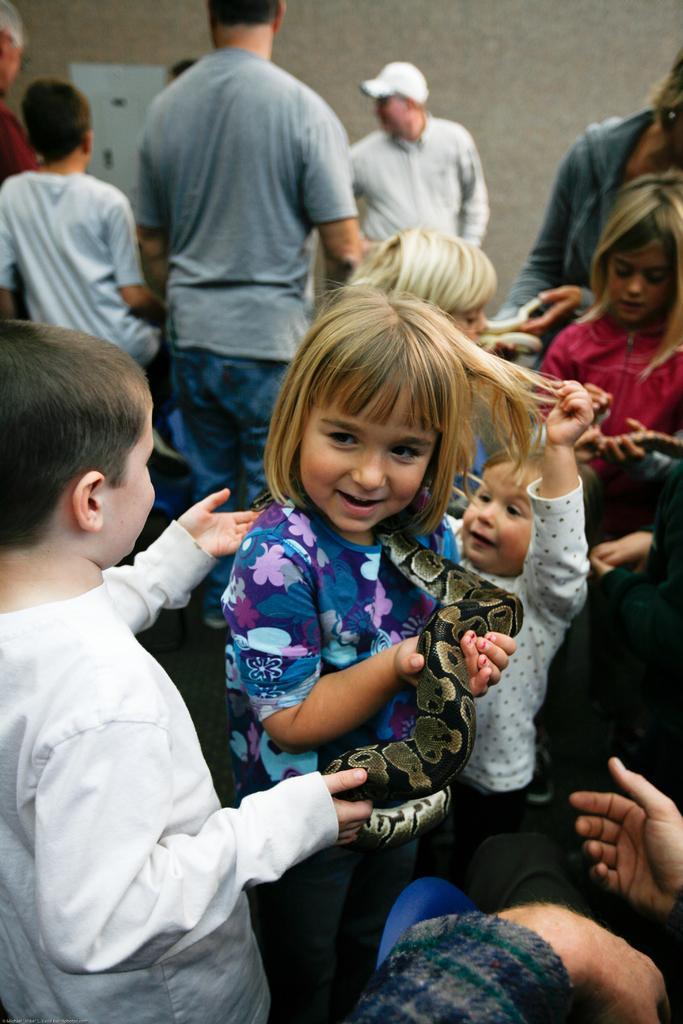How would you summarize this image in a sentence or two? In this image there are group of persons who are playing and at the background of the image there are some persons standing. 